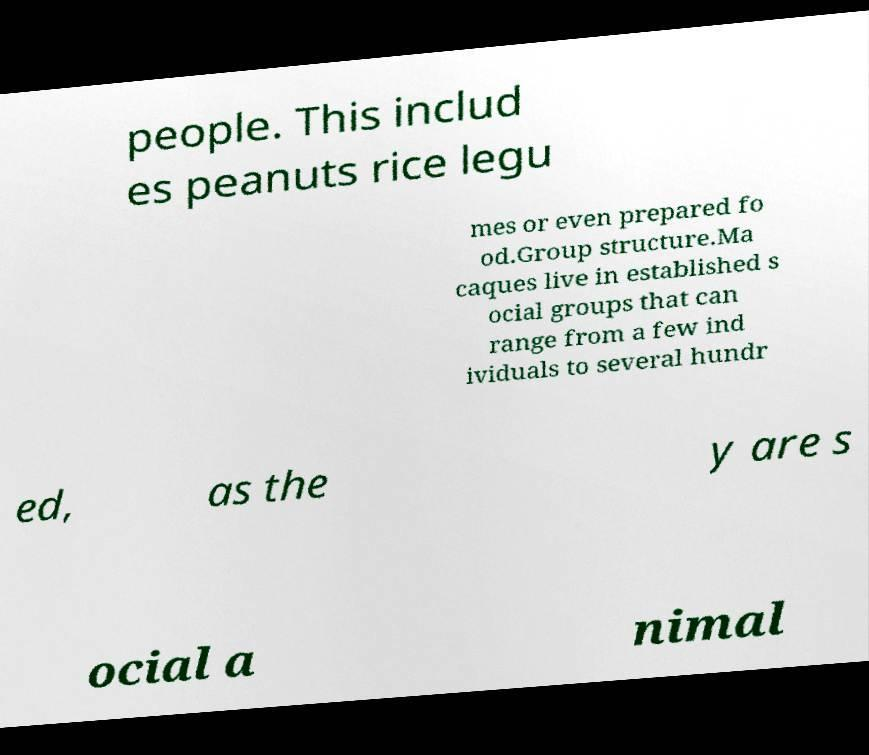Can you accurately transcribe the text from the provided image for me? people. This includ es peanuts rice legu mes or even prepared fo od.Group structure.Ma caques live in established s ocial groups that can range from a few ind ividuals to several hundr ed, as the y are s ocial a nimal 